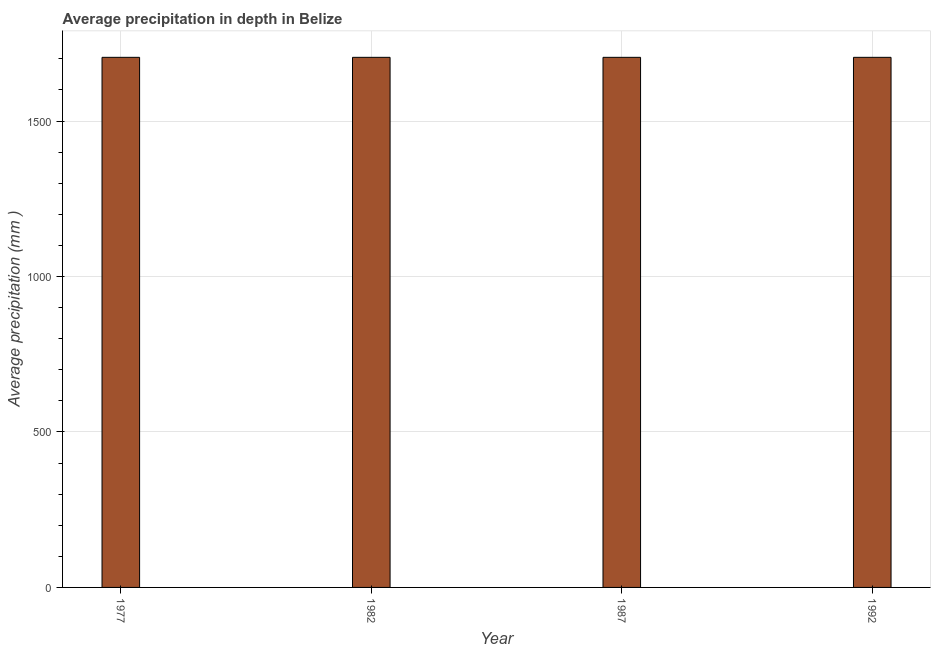Does the graph contain any zero values?
Provide a succinct answer. No. What is the title of the graph?
Provide a short and direct response. Average precipitation in depth in Belize. What is the label or title of the X-axis?
Keep it short and to the point. Year. What is the label or title of the Y-axis?
Your answer should be compact. Average precipitation (mm ). What is the average precipitation in depth in 1987?
Your answer should be very brief. 1705. Across all years, what is the maximum average precipitation in depth?
Give a very brief answer. 1705. Across all years, what is the minimum average precipitation in depth?
Offer a very short reply. 1705. In which year was the average precipitation in depth maximum?
Provide a short and direct response. 1977. In which year was the average precipitation in depth minimum?
Keep it short and to the point. 1977. What is the sum of the average precipitation in depth?
Provide a short and direct response. 6820. What is the difference between the average precipitation in depth in 1982 and 1992?
Offer a very short reply. 0. What is the average average precipitation in depth per year?
Ensure brevity in your answer.  1705. What is the median average precipitation in depth?
Provide a short and direct response. 1705. In how many years, is the average precipitation in depth greater than 300 mm?
Your answer should be compact. 4. What is the ratio of the average precipitation in depth in 1977 to that in 1992?
Give a very brief answer. 1. What is the difference between the highest and the second highest average precipitation in depth?
Make the answer very short. 0. Is the sum of the average precipitation in depth in 1982 and 1987 greater than the maximum average precipitation in depth across all years?
Your answer should be very brief. Yes. What is the difference between the highest and the lowest average precipitation in depth?
Your response must be concise. 0. In how many years, is the average precipitation in depth greater than the average average precipitation in depth taken over all years?
Ensure brevity in your answer.  0. How many bars are there?
Provide a short and direct response. 4. How many years are there in the graph?
Give a very brief answer. 4. What is the Average precipitation (mm ) in 1977?
Ensure brevity in your answer.  1705. What is the Average precipitation (mm ) of 1982?
Your response must be concise. 1705. What is the Average precipitation (mm ) of 1987?
Provide a short and direct response. 1705. What is the Average precipitation (mm ) of 1992?
Give a very brief answer. 1705. What is the difference between the Average precipitation (mm ) in 1982 and 1987?
Make the answer very short. 0. What is the difference between the Average precipitation (mm ) in 1982 and 1992?
Keep it short and to the point. 0. What is the difference between the Average precipitation (mm ) in 1987 and 1992?
Provide a succinct answer. 0. What is the ratio of the Average precipitation (mm ) in 1977 to that in 1982?
Your answer should be compact. 1. What is the ratio of the Average precipitation (mm ) in 1977 to that in 1992?
Offer a terse response. 1. What is the ratio of the Average precipitation (mm ) in 1982 to that in 1992?
Your response must be concise. 1. 